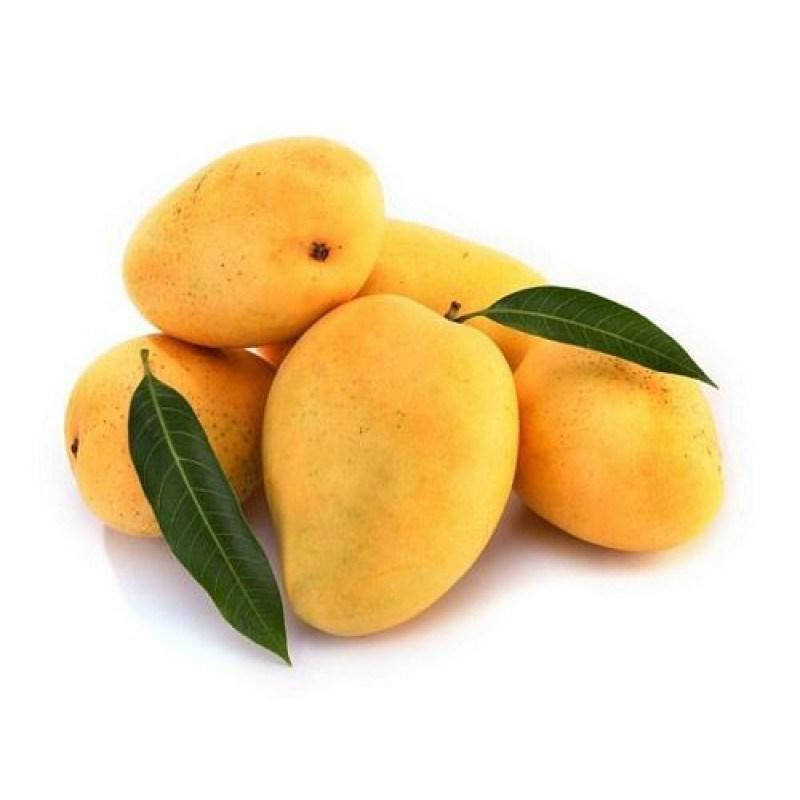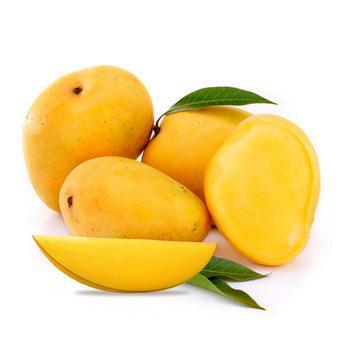The first image is the image on the left, the second image is the image on the right. For the images displayed, is the sentence "Both images contain cut lemons." factually correct? Answer yes or no. No. 